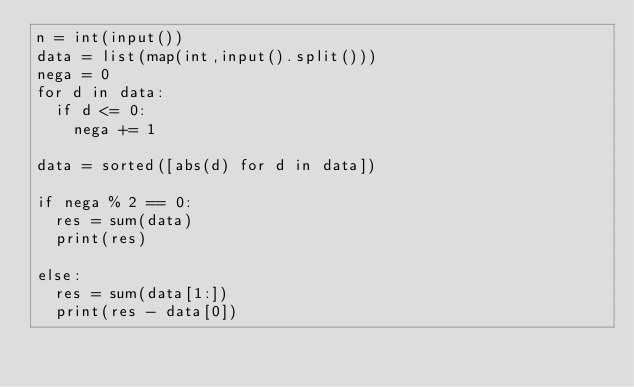Convert code to text. <code><loc_0><loc_0><loc_500><loc_500><_Python_>n = int(input())
data = list(map(int,input().split()))
nega = 0
for d in data:
  if d <= 0:
    nega += 1
    
data = sorted([abs(d) for d in data])
    
if nega % 2 == 0:
  res = sum(data)
  print(res)
  
else:
  res = sum(data[1:])
  print(res - data[0])
  </code> 